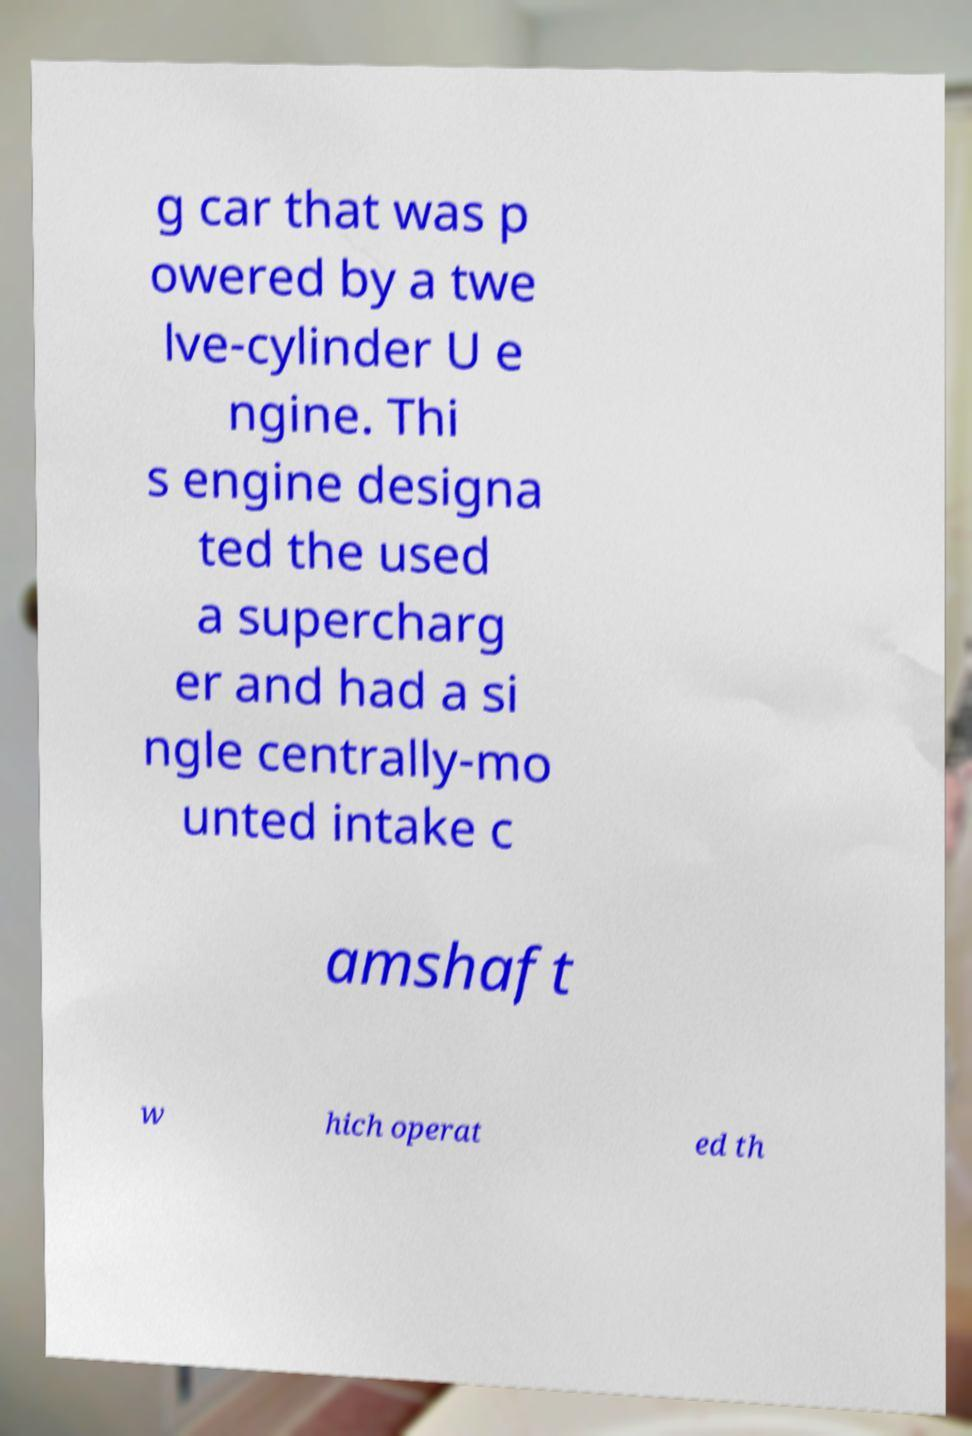Please read and relay the text visible in this image. What does it say? g car that was p owered by a twe lve-cylinder U e ngine. Thi s engine designa ted the used a supercharg er and had a si ngle centrally-mo unted intake c amshaft w hich operat ed th 